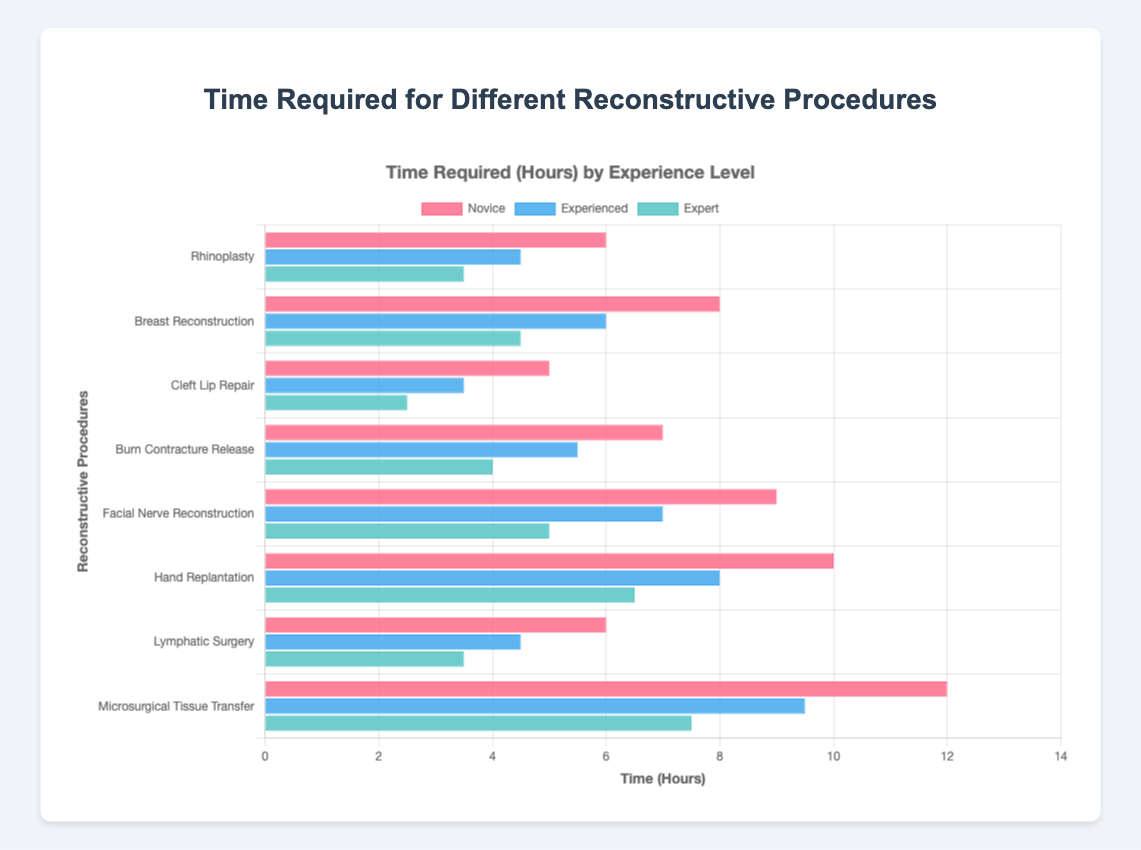Which procedure shows the greatest reduction in time from novice to expert? To determine this, we need to calculate the time reduction for each procedure by subtracting the expert time from the novice time. The calculations are: Rhinoplasty (6 - 3.5 = 2.5 hours), Breast Reconstruction (8 - 4.5 = 3.5 hours), Cleft Lip Repair (5 - 2.5 = 2.5 hours), Burn Contracture Release (7 - 4 = 3 hours), Facial Nerve Reconstruction (9 - 5 = 4 hours), Hand Replantation (10 - 6.5 = 3.5 hours), Lymphatic Surgery (6 - 3.5 = 2.5 hours), Microsurgical Tissue Transfer (12 - 7.5 = 4.5 hours). By comparing these values, Microsurgical Tissue Transfer has the greatest reduction in time (4.5 hours).
Answer: Microsurgical Tissue Transfer Which procedure takes the least amount of time for experts? We look at the expert times for each procedure: Rhinoplasty (3.5 hours), Breast Reconstruction (4.5 hours), Cleft Lip Repair (2.5 hours), Burn Contracture Release (4 hours), Facial Nerve Reconstruction (5 hours), Hand Replantation (6.5 hours), Lymphatic Surgery (3.5 hours), Microsurgical Tissue Transfer (7.5 hours). Cleft Lip Repair has the least time at 2.5 hours.
Answer: Cleft Lip Repair How much longer on average do novice surgeons take compared to experts across all procedures? First, let's find the total time for novice surgeons: (6 + 8 + 5 + 7 + 9 + 10 + 6 + 12) = 63 hours. For experts, the total time is: (3.5 + 4.5 + 2.5 + 4 + 5 + 6.5 + 3.5 + 7.5) = 37 hours. The average time for novices is 63 / 8 = 7.875 hours, and for experts, it is 37 / 8 = 4.625 hours. The difference in average times is 7.875 - 4.625 = 3.25 hours.
Answer: 3.25 hours Which experience level has the most consistent time requirement across all procedures? Consistency can be measured using the range (difference between max and min). For novices, the range is (12 - 5) = 7 hours. For experienced, it is (9.5 - 3.5) = 6 hours. For experts, it is (7.5 - 2.5) = 5 hours. Thus, experts have the most consistent time requirement with a range of 5 hours.
Answer: Expert Which color represents the novice surgeons in the chart? By looking at the colors of the grouped bars, we see that the red bars are associated with novice surgeons as per the legend in the chart.
Answer: Red What's the time difference between novice and experienced surgeons for Breast Reconstruction? For Breast Reconstruction, novices take 8 hours and experienced surgeons take 6 hours. The difference is 8 - 6 = 2 hours.
Answer: 2 hours For which procedure do experienced surgeons take exactly half the time of novice surgeons? To find this, we need to check which procedure has the experienced time exactly half of the novice time: Rhinoplasty (6 / 2 = 3; experienced = 4.5), Breast Reconstruction (8 / 2 = 4; experienced = 6), Cleft Lip Repair (5 / 2 = 2.5; experienced = 3.5), Burn Contracture Release (7 / 2 = 3.5; experienced = 5.5), Facial Nerve Reconstruction (9 / 2 = 4.5; experienced = 7), Hand Replantation (10 / 2 = 5; experienced = 8), Lymphatic Surgery (6 / 2 = 3; experienced = 4.5), Microsurgical Tissue Transfer (12 / 2 = 6; experienced = 9.5). None of the procedures meet this criterion.
Answer: None Which procedure has the smallest difference in time between experienced and expert surgeons? Let's calculate the differences: Rhinoplasty (4.5 - 3.5 = 1 hour), Breast Reconstruction (6 - 4.5 = 1.5 hours), Cleft Lip Repair (3.5 - 2.5 = 1 hour), Burn Contracture Release (5.5 - 4 = 1.5 hours), Facial Nerve Reconstruction (7 - 5 = 2 hours), Hand Replantation (8 - 6.5 = 1.5 hours), Lymphatic Surgery (4.5 - 3.5 = 1 hour), Microsurgical Tissue Transfer (9.5 - 7.5 = 2 hours). The smallest difference is 1 hour, observed in Rhinoplasty, Cleft Lip Repair, and Lymphatic Surgery.
Answer: Rhinoplasty, Cleft Lip Repair, Lymphatic Surgery What is the visual difference in bar height between novice and expert for the longest duration procedure? Microsurgical Tissue Transfer is the longest duration procedure (12 hours for novice). Visually comparing the heights of bars in this procedure, the novice bar is much taller compared to the expert bar.
Answer: Novice bar is much taller 